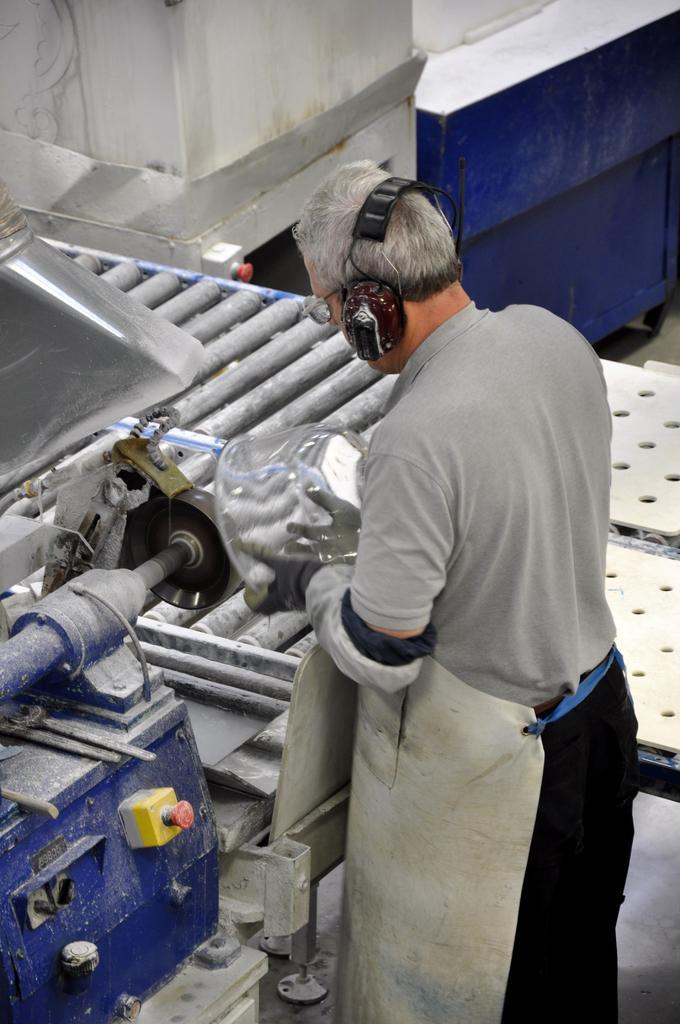Can you describe this image briefly? In this image I can see a person wearing a head and holding an object ,standing in front of the machine ,at the top I can see the wall. 